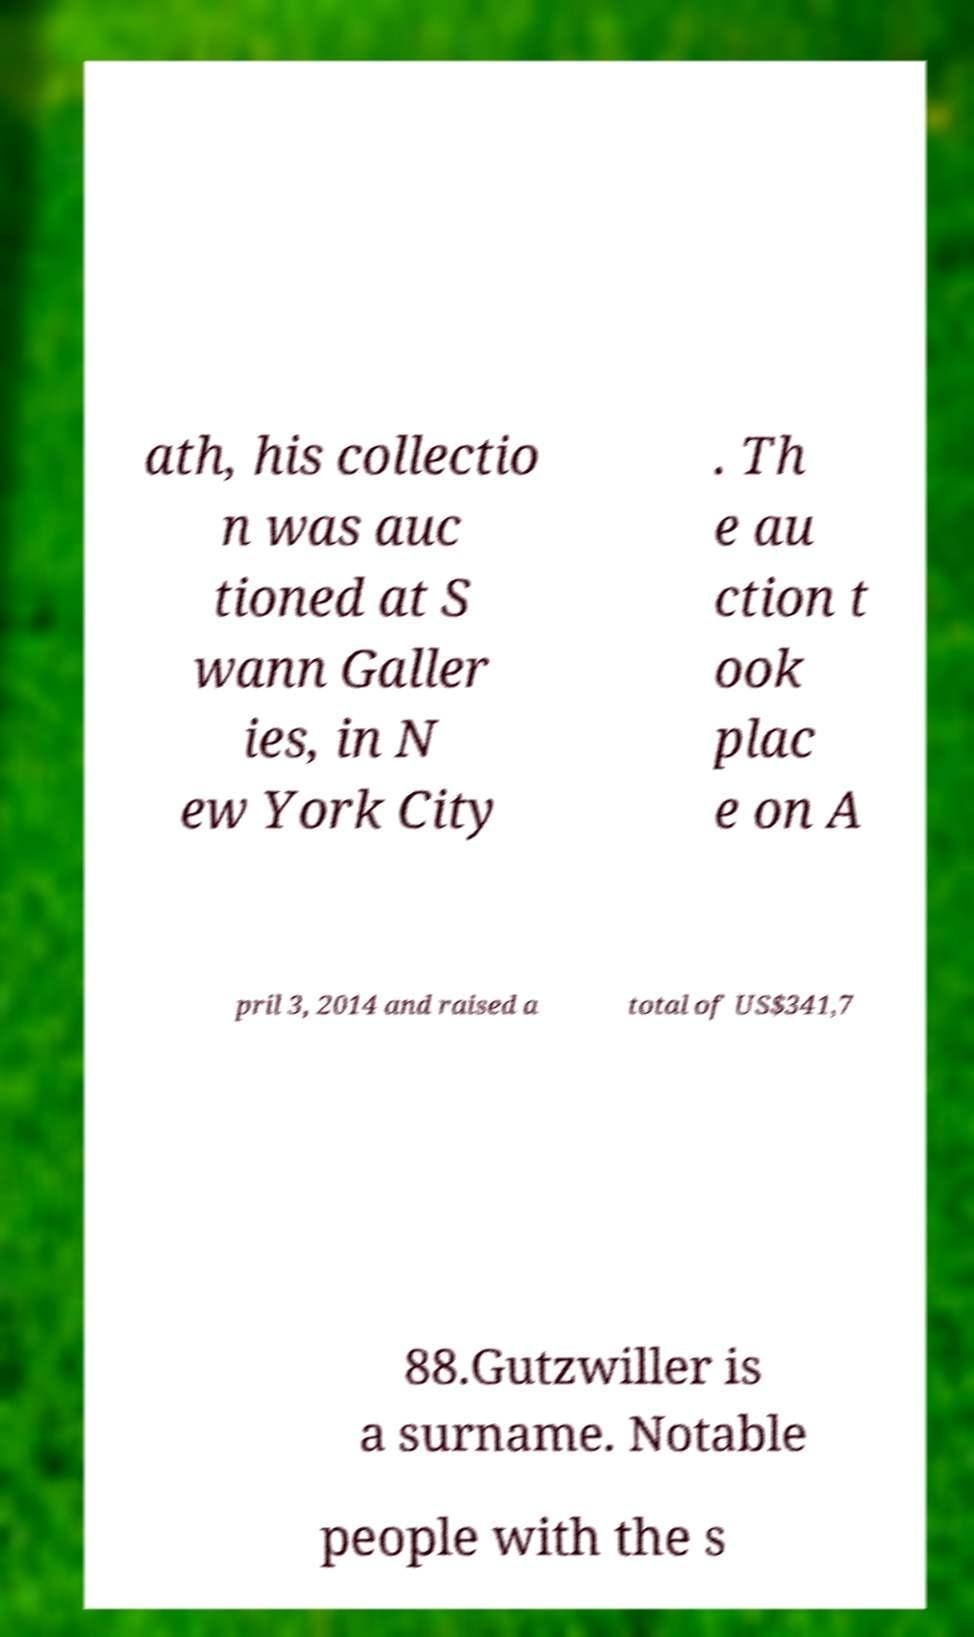What messages or text are displayed in this image? I need them in a readable, typed format. ath, his collectio n was auc tioned at S wann Galler ies, in N ew York City . Th e au ction t ook plac e on A pril 3, 2014 and raised a total of US$341,7 88.Gutzwiller is a surname. Notable people with the s 